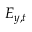Convert formula to latex. <formula><loc_0><loc_0><loc_500><loc_500>E _ { y , t }</formula> 